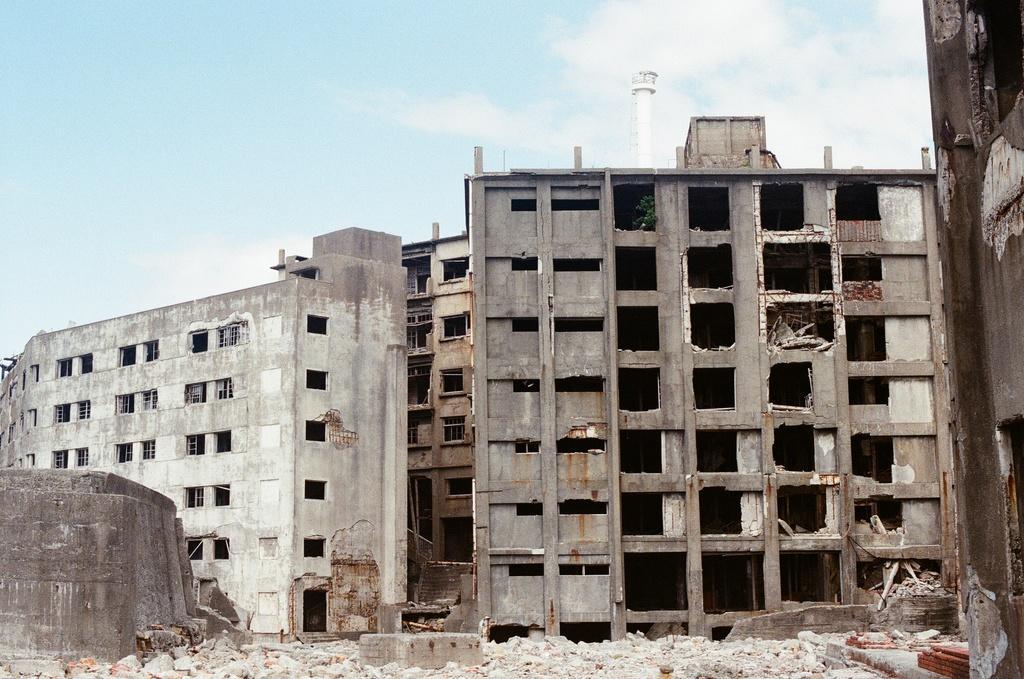Can you describe this image briefly? In this image I can see few buildings which are cream, grey and brown in color and few rocks on the ground. In the background I can see the sky and a white colored tower. 